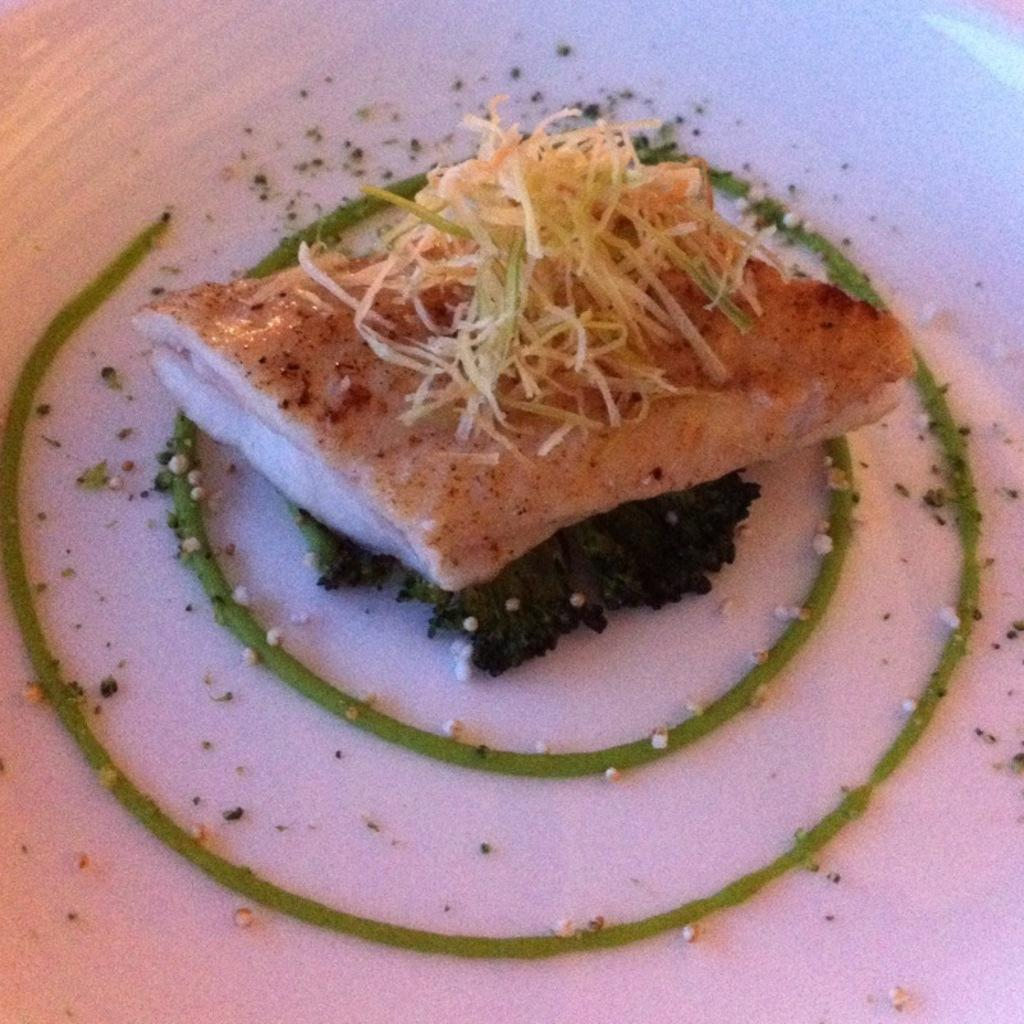What object can be seen in the image that might be used for serving or presenting food? There is a plate in the image that can be used for serving or presenting food. What is on the plate in the image? There is food present on the plate in the image. How many friends are depicted on the canvas in the image? There is no canvas or friends present in the image. What type of toys can be seen on the plate in the image? There are no toys present on the plate in the image; it contains food. 